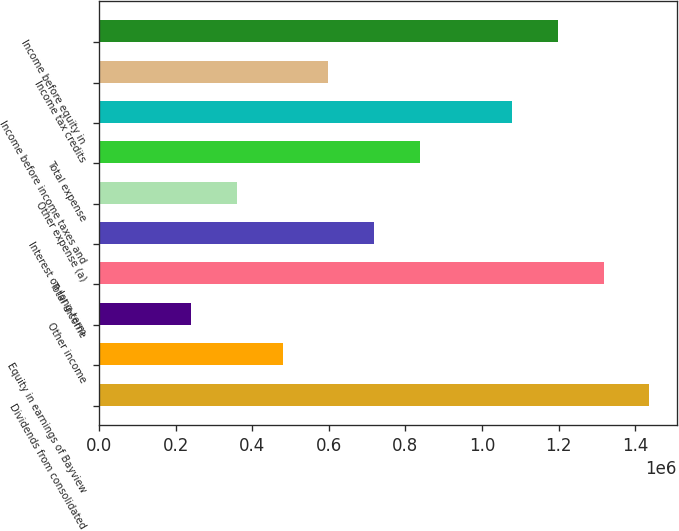Convert chart to OTSL. <chart><loc_0><loc_0><loc_500><loc_500><bar_chart><fcel>Dividends from consolidated<fcel>Equity in earnings of Bayview<fcel>Other income<fcel>Total income<fcel>Interest on long-term<fcel>Other expense (a)<fcel>Total expense<fcel>Income before income taxes and<fcel>Income tax credits<fcel>Income before equity in<nl><fcel>1.43728e+06<fcel>479100<fcel>239554<fcel>1.31751e+06<fcel>718645<fcel>359327<fcel>838418<fcel>1.07796e+06<fcel>598873<fcel>1.19774e+06<nl></chart> 